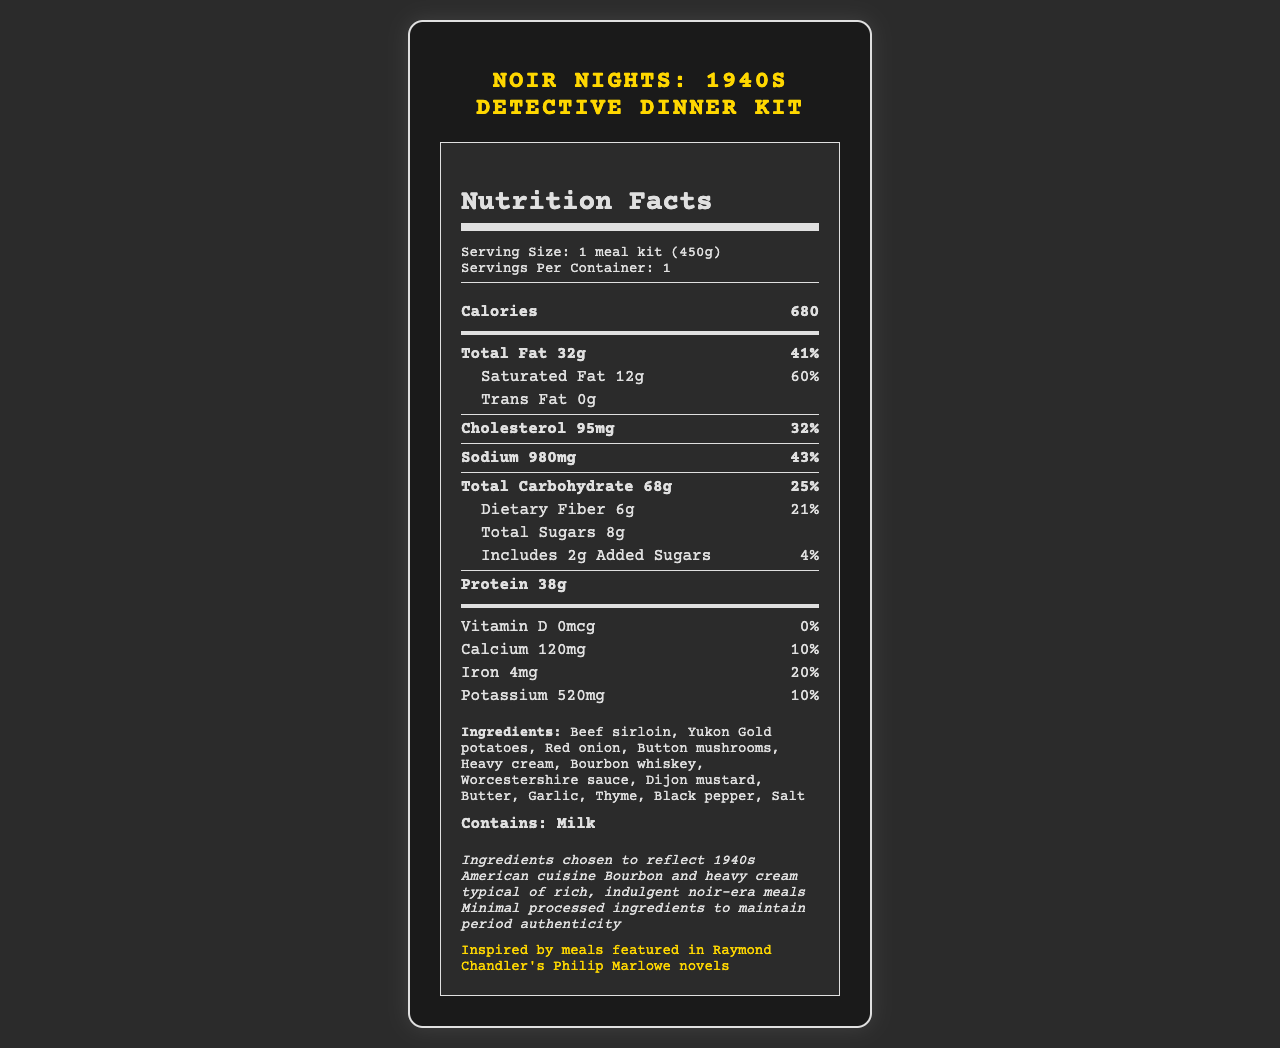what is the product name? The product name is listed at the top of the document.
Answer: Noir Nights: 1940s Detective Dinner Kit how many calories are in one serving? The nutrition label indicates that there are 680 calories.
Answer: 680 what is the serving size of the meal kit? The serving size is stated as "1 meal kit (450g)" in the serving info section.
Answer: 1 meal kit (450g) how many grams of protein does the meal kit contain? The amount of protein is listed as 38g in the nutrient section.
Answer: 38g which era does the meal kit aim to reflect with its ingredients? The "era authenticity notes" state it reflects 1940s American cuisine.
Answer: 1940s American cuisine what ingredients are included in the meal kit? The ingredients are listed in the ingredients section.
Answer: Beef sirloin, Yukon Gold potatoes, Red onion, Button mushrooms, Heavy cream, Bourbon whiskey, Worcestershire sauce, Dijon mustard, Butter, Garlic, Thyme, Black pepper, Salt what is the daily value percentage for saturated fat in the meal kit? The daily value for saturated fat is listed as 60%.
Answer: 60% how much sodium does the meal kit contain? The sodium content is listed as 980mg.
Answer: 980mg what is the main connection to crime fiction mentioned in the document? The crime fiction connection section mentions the inspiration from Raymond Chandler's Philip Marlowe novels.
Answer: Inspired by meals featured in Raymond Chandler's Philip Marlowe novels when refrigerated, how long is the shelf life of the meal kit? The shelf life when refrigerated is stated as 3 days.
Answer: 3 days which of the following nutrients does the meal kit contain the most of? A. Calcium B. Iron C. Potassium D. Dietary Fiber Potassium is listed at 520mg, which is higher than calcium (120mg), iron (4mg), and dietary fiber (6g).
Answer: C. Potassium which ingredient in the meal kit is a source of allergens? (choose the correct option) I. Beef sirloin II. Yukon Gold potatoes III. Heavy cream IV. Dijon mustard The allergens section indicates the meal kit contains "Milk," and heavy cream is the relevant ingredient.
Answer: III. Heavy cream does the meal kit contain trans fat? The document states that the meal kit contains 0g trans fat.
Answer: No does the meal kit use minimal processed ingredients to maintain period authenticity? The era authenticity notes indicate that minimal processed ingredients are used to maintain period authenticity.
Answer: Yes summarize the main aspects of this document The document provides a comprehensive overview of the meal kit's nutrition, historical inspiration, and packaging, highlighting its connection to 1940s crime fiction and its attempt to remain period-authentic in its ingredients.
Answer: The document describes the nutrition facts, ingredients, and historical context of the "Noir Nights: 1940s Detective Dinner Kit." It includes specific information about serving size, nutritional content, authenticity notes related to 1940s American cuisine, and its inspiration from Raymond Chandler's Philip Marlowe novels. Additionally, it specifies allergens, preparation time, and shelf life, emphasizing the use of recyclable and compostable packaging. what is the origin of the product idea? The document does not provide detailed information about the origin of the product idea beyond its inspiration from Raymond Chandler's novels.
Answer: Not enough information 